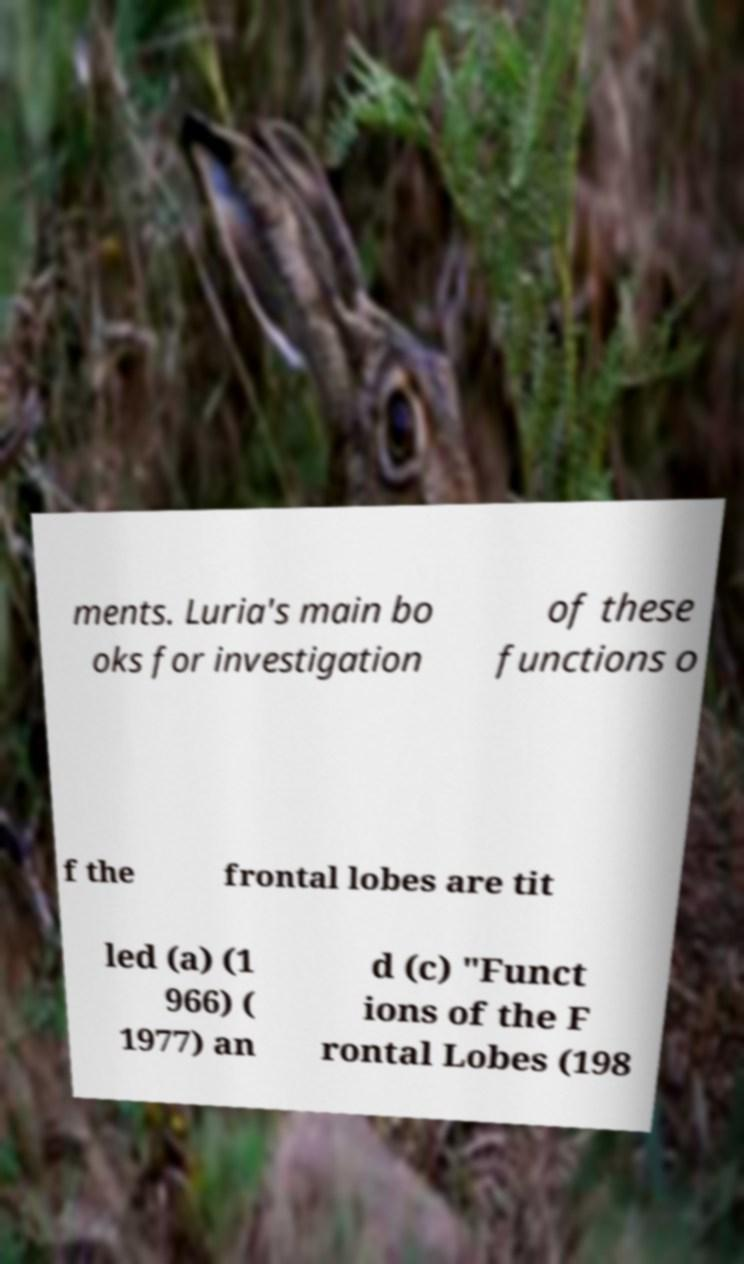Can you accurately transcribe the text from the provided image for me? ments. Luria's main bo oks for investigation of these functions o f the frontal lobes are tit led (a) (1 966) ( 1977) an d (c) "Funct ions of the F rontal Lobes (198 